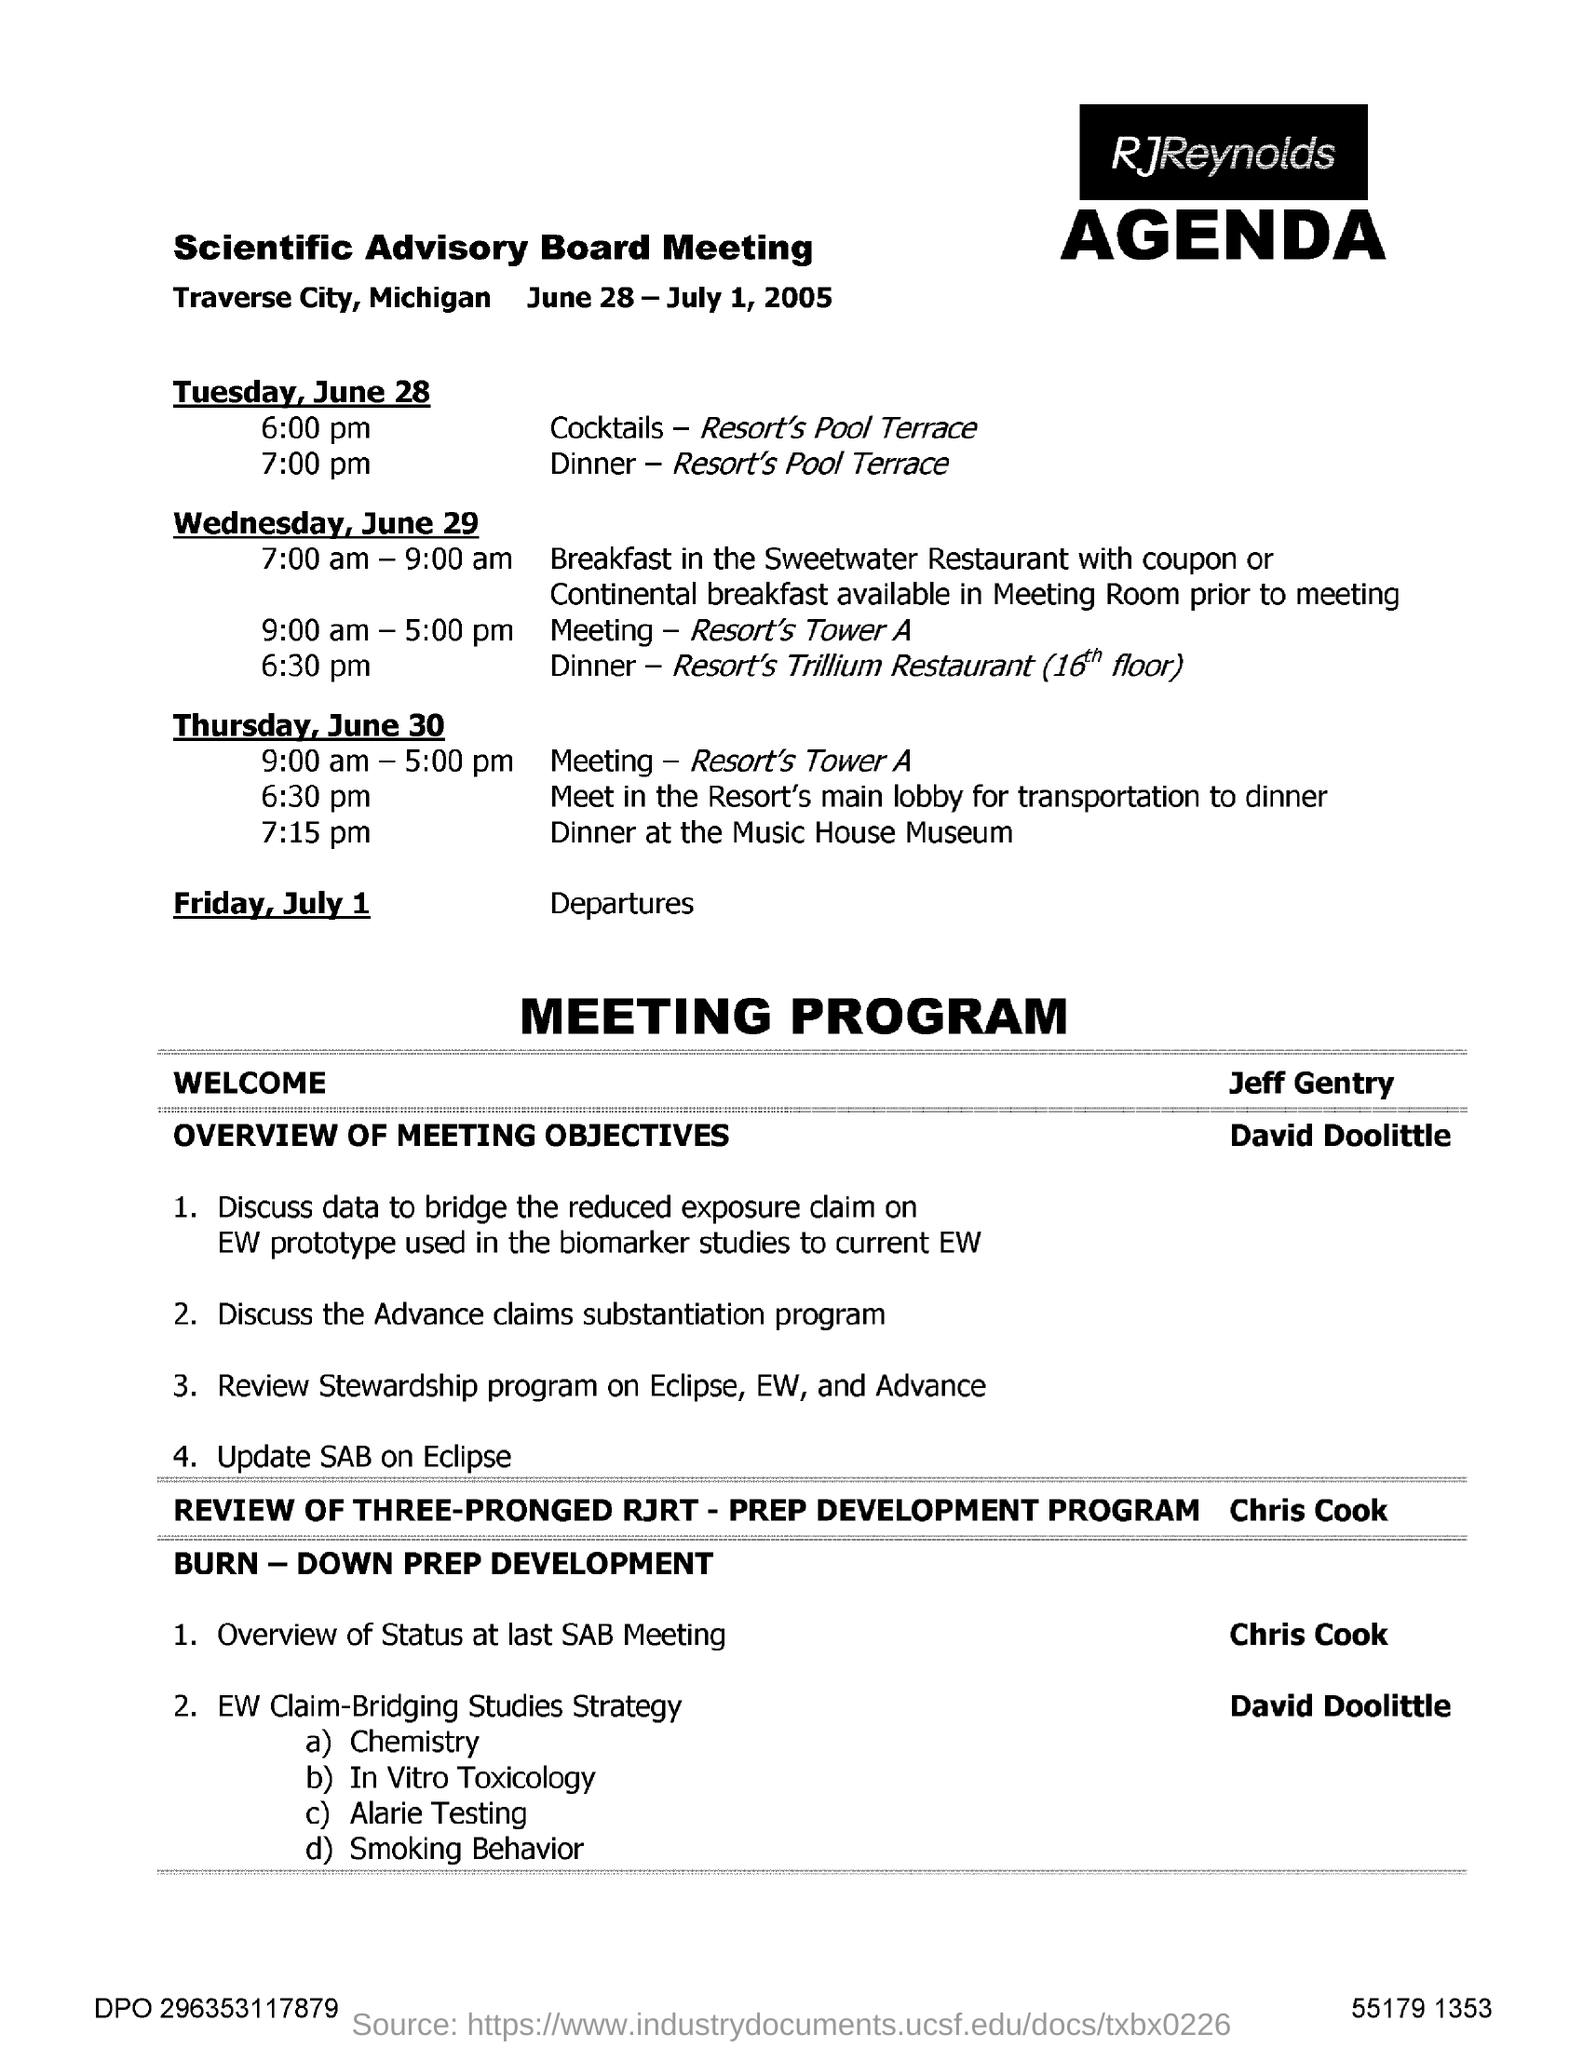Outline some significant characteristics in this image. On Wednesday, June 29, the dinner will be held at the Resort's Trillium Restaurant, which is located on the 16th floor. On Tuesday, June 28, the dinner will be held at the Resort's Pool Terrace. The Scientific Advisory Board Meeting was held from June 28 to July 1, 2005. 